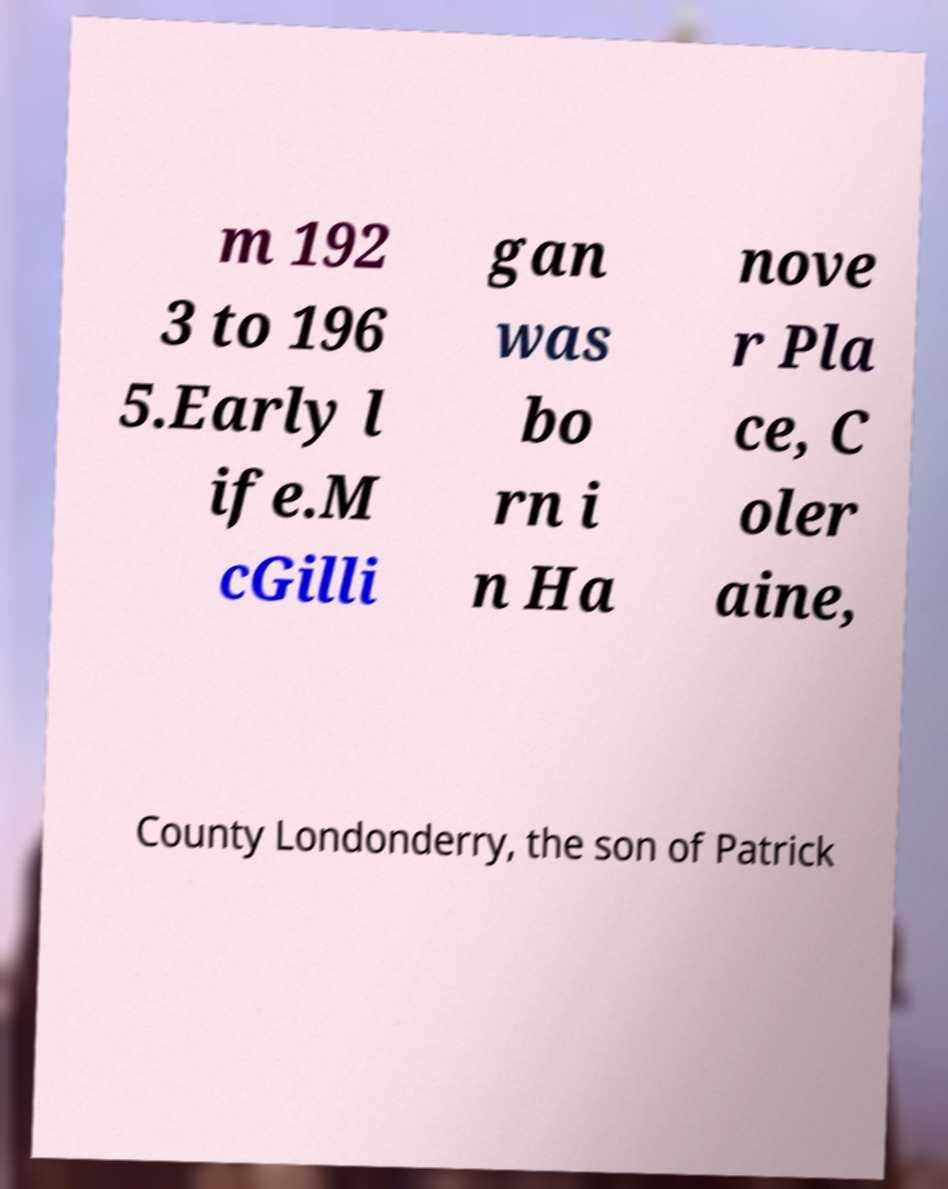Please read and relay the text visible in this image. What does it say? m 192 3 to 196 5.Early l ife.M cGilli gan was bo rn i n Ha nove r Pla ce, C oler aine, County Londonderry, the son of Patrick 